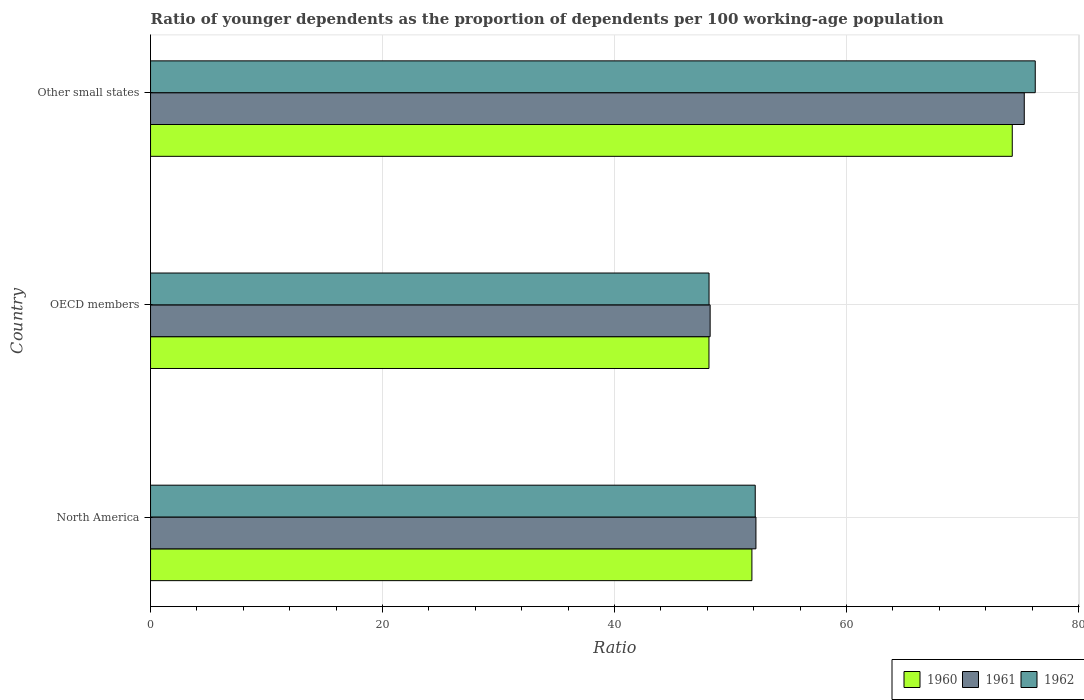How many different coloured bars are there?
Give a very brief answer. 3. How many groups of bars are there?
Make the answer very short. 3. Are the number of bars per tick equal to the number of legend labels?
Make the answer very short. Yes. In how many cases, is the number of bars for a given country not equal to the number of legend labels?
Your answer should be compact. 0. What is the age dependency ratio(young) in 1961 in OECD members?
Provide a succinct answer. 48.25. Across all countries, what is the maximum age dependency ratio(young) in 1961?
Offer a very short reply. 75.33. Across all countries, what is the minimum age dependency ratio(young) in 1962?
Your answer should be compact. 48.15. In which country was the age dependency ratio(young) in 1960 maximum?
Offer a very short reply. Other small states. What is the total age dependency ratio(young) in 1960 in the graph?
Keep it short and to the point. 174.29. What is the difference between the age dependency ratio(young) in 1962 in North America and that in Other small states?
Provide a succinct answer. -24.14. What is the difference between the age dependency ratio(young) in 1961 in Other small states and the age dependency ratio(young) in 1960 in OECD members?
Offer a very short reply. 27.18. What is the average age dependency ratio(young) in 1961 per country?
Ensure brevity in your answer.  58.59. What is the difference between the age dependency ratio(young) in 1962 and age dependency ratio(young) in 1961 in North America?
Ensure brevity in your answer.  -0.06. In how many countries, is the age dependency ratio(young) in 1960 greater than 52 ?
Make the answer very short. 1. What is the ratio of the age dependency ratio(young) in 1960 in North America to that in OECD members?
Offer a very short reply. 1.08. Is the age dependency ratio(young) in 1960 in North America less than that in Other small states?
Make the answer very short. Yes. What is the difference between the highest and the second highest age dependency ratio(young) in 1960?
Your response must be concise. 22.45. What is the difference between the highest and the lowest age dependency ratio(young) in 1961?
Keep it short and to the point. 27.08. In how many countries, is the age dependency ratio(young) in 1961 greater than the average age dependency ratio(young) in 1961 taken over all countries?
Make the answer very short. 1. Is the sum of the age dependency ratio(young) in 1961 in North America and OECD members greater than the maximum age dependency ratio(young) in 1960 across all countries?
Ensure brevity in your answer.  Yes. What does the 1st bar from the top in Other small states represents?
Make the answer very short. 1962. Is it the case that in every country, the sum of the age dependency ratio(young) in 1960 and age dependency ratio(young) in 1962 is greater than the age dependency ratio(young) in 1961?
Offer a very short reply. Yes. How many countries are there in the graph?
Your response must be concise. 3. Are the values on the major ticks of X-axis written in scientific E-notation?
Offer a very short reply. No. How are the legend labels stacked?
Make the answer very short. Horizontal. What is the title of the graph?
Your answer should be very brief. Ratio of younger dependents as the proportion of dependents per 100 working-age population. What is the label or title of the X-axis?
Give a very brief answer. Ratio. What is the Ratio of 1960 in North America?
Offer a terse response. 51.85. What is the Ratio in 1961 in North America?
Offer a terse response. 52.2. What is the Ratio in 1962 in North America?
Ensure brevity in your answer.  52.13. What is the Ratio in 1960 in OECD members?
Provide a short and direct response. 48.15. What is the Ratio in 1961 in OECD members?
Your answer should be very brief. 48.25. What is the Ratio in 1962 in OECD members?
Give a very brief answer. 48.15. What is the Ratio in 1960 in Other small states?
Your answer should be compact. 74.29. What is the Ratio of 1961 in Other small states?
Your response must be concise. 75.33. What is the Ratio of 1962 in Other small states?
Your answer should be very brief. 76.28. Across all countries, what is the maximum Ratio in 1960?
Make the answer very short. 74.29. Across all countries, what is the maximum Ratio of 1961?
Give a very brief answer. 75.33. Across all countries, what is the maximum Ratio in 1962?
Provide a short and direct response. 76.28. Across all countries, what is the minimum Ratio in 1960?
Offer a very short reply. 48.15. Across all countries, what is the minimum Ratio of 1961?
Provide a succinct answer. 48.25. Across all countries, what is the minimum Ratio in 1962?
Your answer should be compact. 48.15. What is the total Ratio in 1960 in the graph?
Provide a short and direct response. 174.29. What is the total Ratio of 1961 in the graph?
Your answer should be very brief. 175.77. What is the total Ratio in 1962 in the graph?
Your answer should be very brief. 176.56. What is the difference between the Ratio of 1960 in North America and that in OECD members?
Ensure brevity in your answer.  3.7. What is the difference between the Ratio of 1961 in North America and that in OECD members?
Your answer should be compact. 3.95. What is the difference between the Ratio in 1962 in North America and that in OECD members?
Provide a short and direct response. 3.98. What is the difference between the Ratio of 1960 in North America and that in Other small states?
Offer a terse response. -22.45. What is the difference between the Ratio in 1961 in North America and that in Other small states?
Your answer should be compact. -23.13. What is the difference between the Ratio in 1962 in North America and that in Other small states?
Your response must be concise. -24.14. What is the difference between the Ratio in 1960 in OECD members and that in Other small states?
Your response must be concise. -26.15. What is the difference between the Ratio in 1961 in OECD members and that in Other small states?
Ensure brevity in your answer.  -27.08. What is the difference between the Ratio in 1962 in OECD members and that in Other small states?
Give a very brief answer. -28.13. What is the difference between the Ratio of 1960 in North America and the Ratio of 1961 in OECD members?
Offer a terse response. 3.6. What is the difference between the Ratio of 1960 in North America and the Ratio of 1962 in OECD members?
Your response must be concise. 3.7. What is the difference between the Ratio of 1961 in North America and the Ratio of 1962 in OECD members?
Ensure brevity in your answer.  4.04. What is the difference between the Ratio in 1960 in North America and the Ratio in 1961 in Other small states?
Keep it short and to the point. -23.48. What is the difference between the Ratio of 1960 in North America and the Ratio of 1962 in Other small states?
Your answer should be compact. -24.43. What is the difference between the Ratio in 1961 in North America and the Ratio in 1962 in Other small states?
Your answer should be compact. -24.08. What is the difference between the Ratio in 1960 in OECD members and the Ratio in 1961 in Other small states?
Your answer should be compact. -27.18. What is the difference between the Ratio of 1960 in OECD members and the Ratio of 1962 in Other small states?
Your answer should be very brief. -28.13. What is the difference between the Ratio in 1961 in OECD members and the Ratio in 1962 in Other small states?
Offer a very short reply. -28.03. What is the average Ratio in 1960 per country?
Your response must be concise. 58.1. What is the average Ratio in 1961 per country?
Your answer should be very brief. 58.59. What is the average Ratio of 1962 per country?
Your answer should be very brief. 58.85. What is the difference between the Ratio of 1960 and Ratio of 1961 in North America?
Ensure brevity in your answer.  -0.35. What is the difference between the Ratio in 1960 and Ratio in 1962 in North America?
Offer a very short reply. -0.29. What is the difference between the Ratio in 1961 and Ratio in 1962 in North America?
Your answer should be very brief. 0.06. What is the difference between the Ratio of 1960 and Ratio of 1961 in OECD members?
Ensure brevity in your answer.  -0.1. What is the difference between the Ratio of 1960 and Ratio of 1962 in OECD members?
Your response must be concise. -0.01. What is the difference between the Ratio in 1961 and Ratio in 1962 in OECD members?
Provide a short and direct response. 0.09. What is the difference between the Ratio in 1960 and Ratio in 1961 in Other small states?
Offer a very short reply. -1.04. What is the difference between the Ratio of 1960 and Ratio of 1962 in Other small states?
Offer a very short reply. -1.98. What is the difference between the Ratio of 1961 and Ratio of 1962 in Other small states?
Provide a short and direct response. -0.95. What is the ratio of the Ratio in 1961 in North America to that in OECD members?
Offer a terse response. 1.08. What is the ratio of the Ratio of 1962 in North America to that in OECD members?
Your answer should be very brief. 1.08. What is the ratio of the Ratio in 1960 in North America to that in Other small states?
Offer a terse response. 0.7. What is the ratio of the Ratio in 1961 in North America to that in Other small states?
Your answer should be compact. 0.69. What is the ratio of the Ratio in 1962 in North America to that in Other small states?
Offer a very short reply. 0.68. What is the ratio of the Ratio in 1960 in OECD members to that in Other small states?
Offer a terse response. 0.65. What is the ratio of the Ratio in 1961 in OECD members to that in Other small states?
Your response must be concise. 0.64. What is the ratio of the Ratio in 1962 in OECD members to that in Other small states?
Keep it short and to the point. 0.63. What is the difference between the highest and the second highest Ratio in 1960?
Your answer should be compact. 22.45. What is the difference between the highest and the second highest Ratio of 1961?
Your answer should be compact. 23.13. What is the difference between the highest and the second highest Ratio in 1962?
Your response must be concise. 24.14. What is the difference between the highest and the lowest Ratio of 1960?
Offer a terse response. 26.15. What is the difference between the highest and the lowest Ratio of 1961?
Your response must be concise. 27.08. What is the difference between the highest and the lowest Ratio in 1962?
Provide a short and direct response. 28.13. 